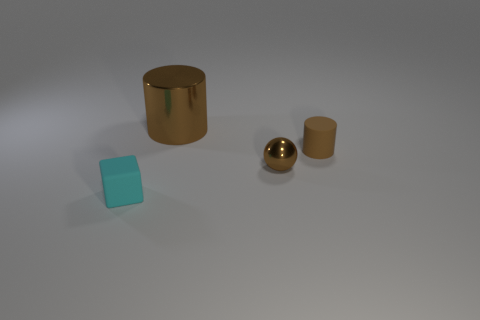Subtract all brown cylinders. How many were subtracted if there are1brown cylinders left? 1 Add 2 green matte objects. How many objects exist? 6 Subtract all balls. How many objects are left? 3 Subtract 0 red spheres. How many objects are left? 4 Subtract all tiny rubber things. Subtract all metallic spheres. How many objects are left? 1 Add 2 brown things. How many brown things are left? 5 Add 4 small brown metallic objects. How many small brown metallic objects exist? 5 